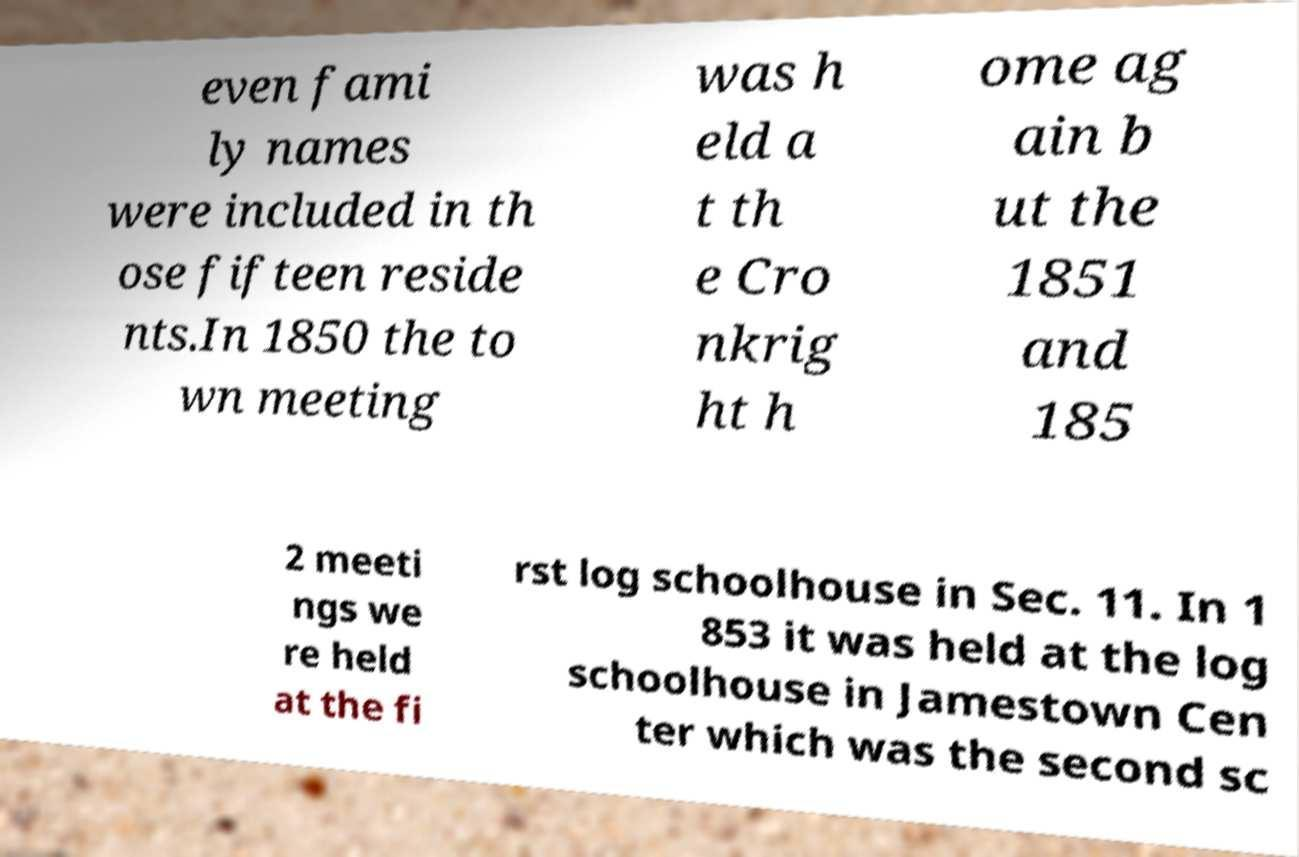There's text embedded in this image that I need extracted. Can you transcribe it verbatim? even fami ly names were included in th ose fifteen reside nts.In 1850 the to wn meeting was h eld a t th e Cro nkrig ht h ome ag ain b ut the 1851 and 185 2 meeti ngs we re held at the fi rst log schoolhouse in Sec. 11. In 1 853 it was held at the log schoolhouse in Jamestown Cen ter which was the second sc 